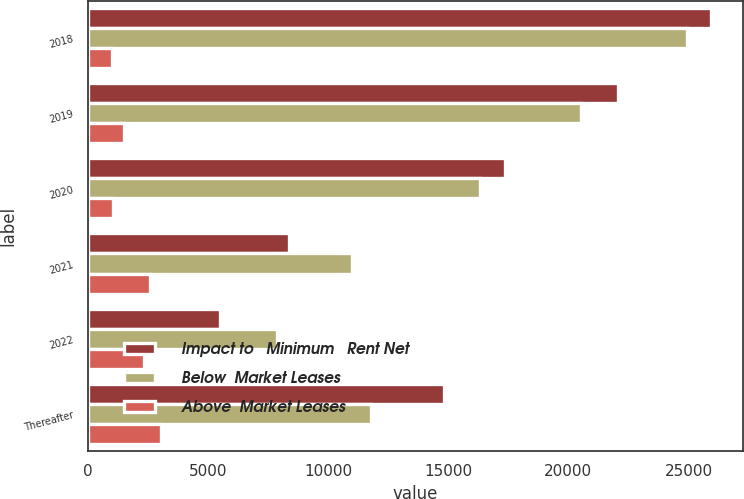Convert chart. <chart><loc_0><loc_0><loc_500><loc_500><stacked_bar_chart><ecel><fcel>2018<fcel>2019<fcel>2020<fcel>2021<fcel>2022<fcel>Thereafter<nl><fcel>Impact to   Minimum   Rent Net<fcel>25953<fcel>22048<fcel>17376<fcel>8395<fcel>5506<fcel>14820<nl><fcel>Below  Market Leases<fcel>24932<fcel>20537<fcel>16305<fcel>10984<fcel>7876<fcel>11771<nl><fcel>Above  Market Leases<fcel>1021<fcel>1511<fcel>1071<fcel>2589<fcel>2370<fcel>3049<nl></chart> 